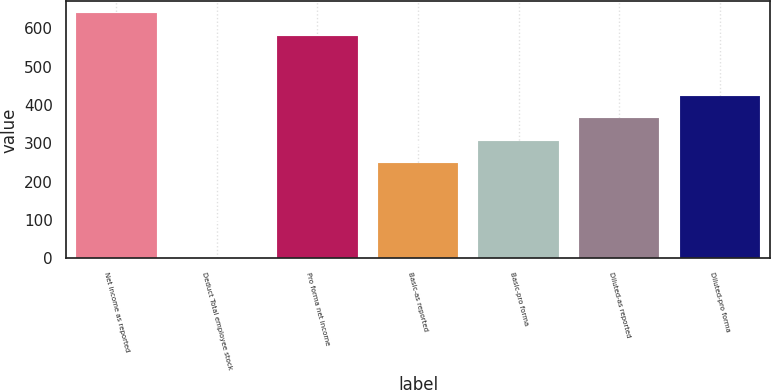Convert chart to OTSL. <chart><loc_0><loc_0><loc_500><loc_500><bar_chart><fcel>Net income as reported<fcel>Deduct Total employee stock<fcel>Pro forma net income<fcel>Basic-as reported<fcel>Basic-pro forma<fcel>Diluted-as reported<fcel>Diluted-pro forma<nl><fcel>639.1<fcel>1<fcel>581<fcel>249<fcel>307.1<fcel>365.2<fcel>423.3<nl></chart> 